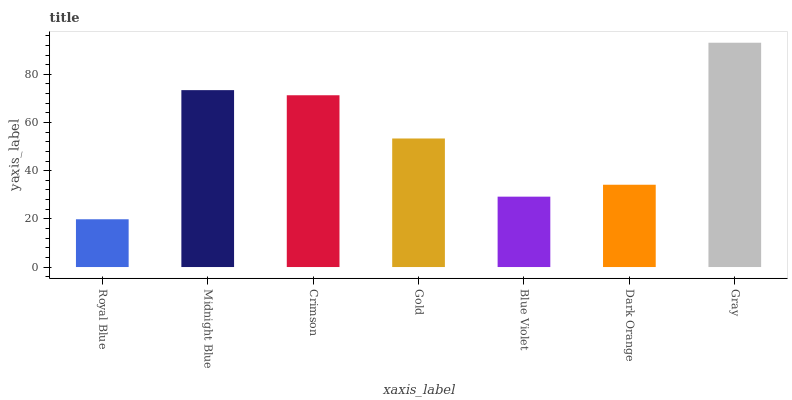Is Royal Blue the minimum?
Answer yes or no. Yes. Is Gray the maximum?
Answer yes or no. Yes. Is Midnight Blue the minimum?
Answer yes or no. No. Is Midnight Blue the maximum?
Answer yes or no. No. Is Midnight Blue greater than Royal Blue?
Answer yes or no. Yes. Is Royal Blue less than Midnight Blue?
Answer yes or no. Yes. Is Royal Blue greater than Midnight Blue?
Answer yes or no. No. Is Midnight Blue less than Royal Blue?
Answer yes or no. No. Is Gold the high median?
Answer yes or no. Yes. Is Gold the low median?
Answer yes or no. Yes. Is Midnight Blue the high median?
Answer yes or no. No. Is Crimson the low median?
Answer yes or no. No. 